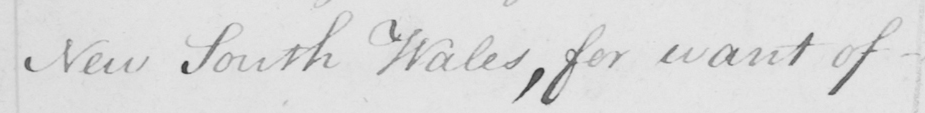What is written in this line of handwriting? New South Wales , for want of 